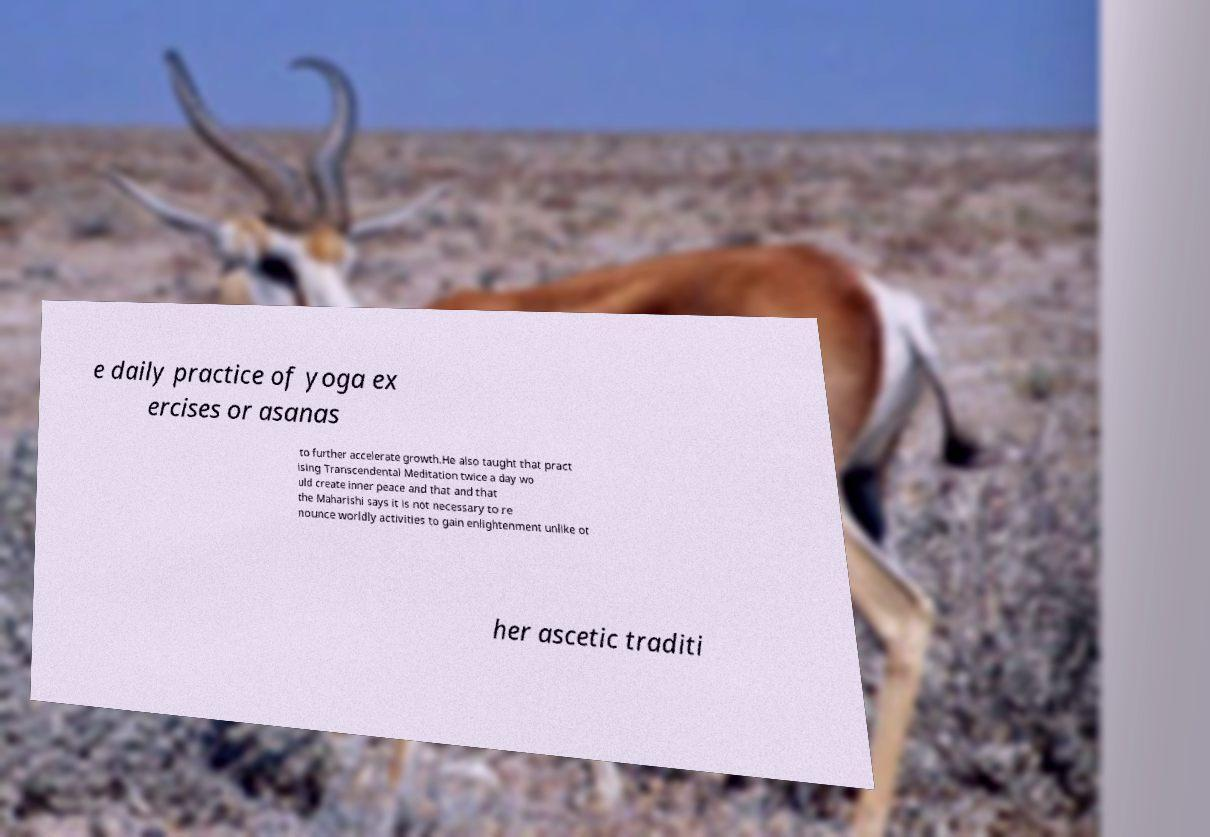Could you extract and type out the text from this image? e daily practice of yoga ex ercises or asanas to further accelerate growth.He also taught that pract ising Transcendental Meditation twice a day wo uld create inner peace and that and that the Maharishi says it is not necessary to re nounce worldly activities to gain enlightenment unlike ot her ascetic traditi 